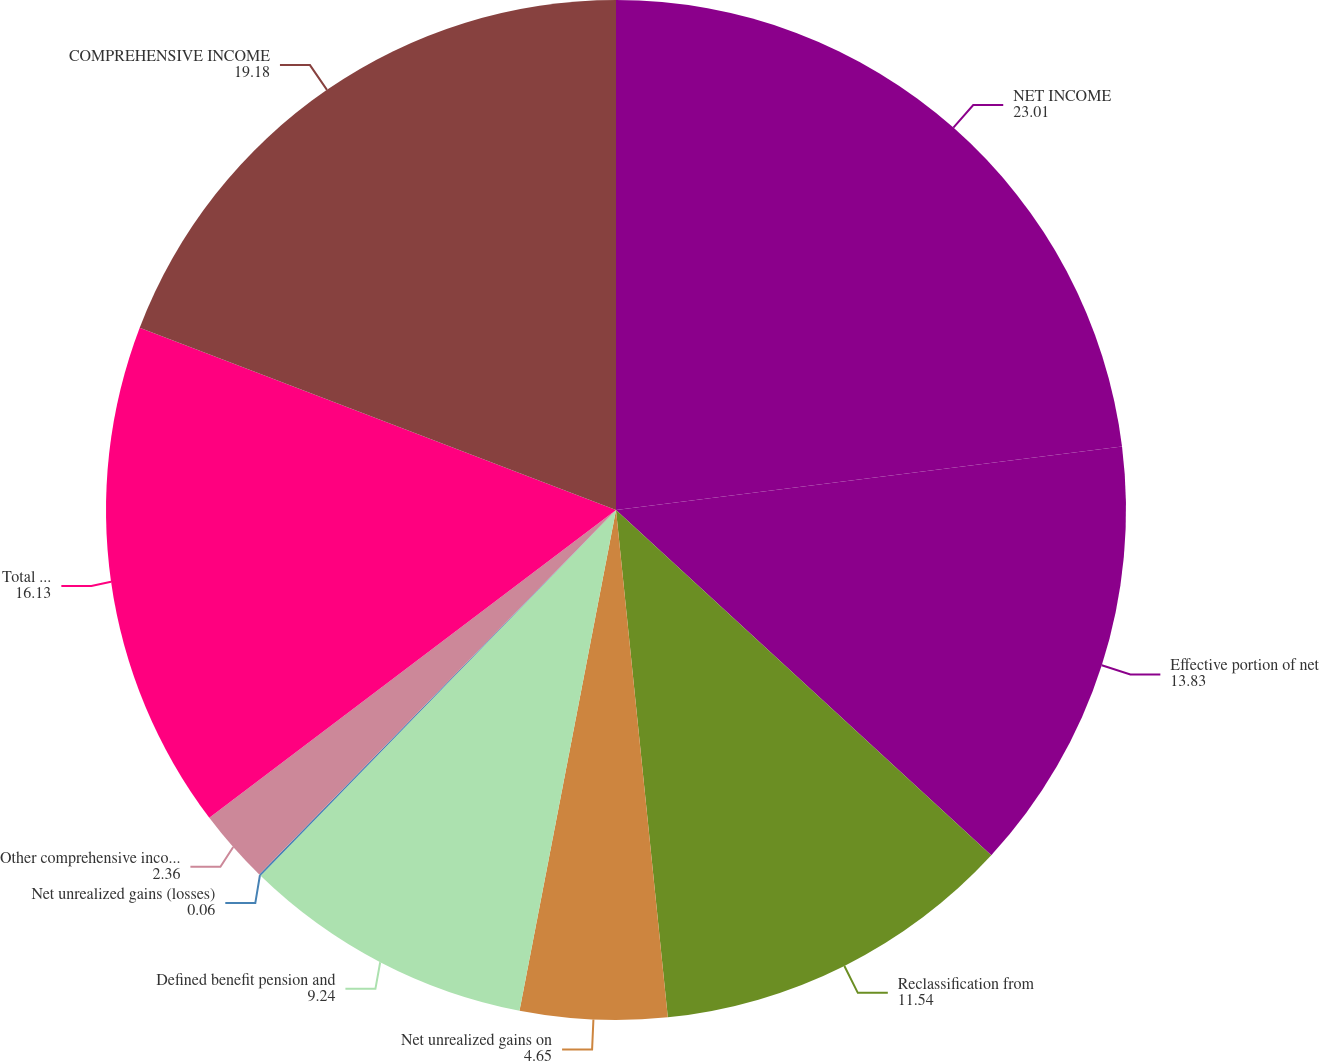Convert chart to OTSL. <chart><loc_0><loc_0><loc_500><loc_500><pie_chart><fcel>NET INCOME<fcel>Effective portion of net<fcel>Reclassification from<fcel>Net unrealized gains on<fcel>Defined benefit pension and<fcel>Net unrealized gains (losses)<fcel>Other comprehensive income<fcel>Total other comprehensive<fcel>COMPREHENSIVE INCOME<nl><fcel>23.01%<fcel>13.83%<fcel>11.54%<fcel>4.65%<fcel>9.24%<fcel>0.06%<fcel>2.36%<fcel>16.13%<fcel>19.18%<nl></chart> 